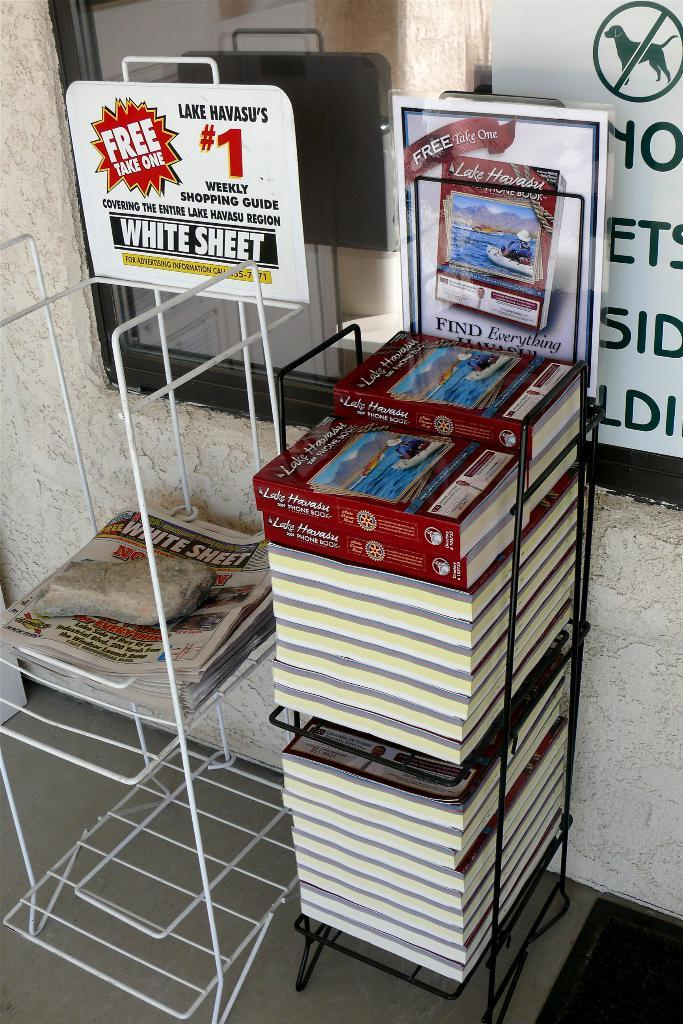Provide a one-sentence caption for the provided image. a stack of books that say lake havasu on the cover of them. 